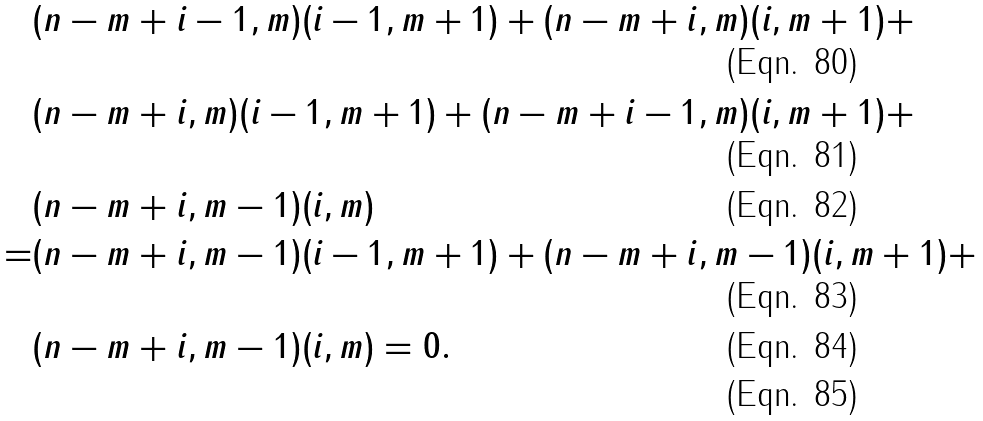<formula> <loc_0><loc_0><loc_500><loc_500>& ( n - m + i - 1 , m ) ( i - 1 , m + 1 ) + ( n - m + i , m ) ( i , m + 1 ) + \\ & ( n - m + i , m ) ( i - 1 , m + 1 ) + ( n - m + i - 1 , m ) ( i , m + 1 ) + \\ & ( n - m + i , m - 1 ) ( i , m ) \\ = & ( n - m + i , m - 1 ) ( i - 1 , m + 1 ) + ( n - m + i , m - 1 ) ( i , m + 1 ) + \\ & ( n - m + i , m - 1 ) ( i , m ) = 0 . \\</formula> 